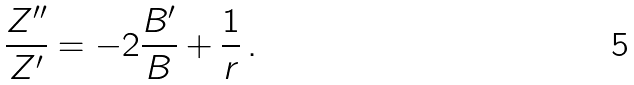<formula> <loc_0><loc_0><loc_500><loc_500>\frac { Z ^ { \prime \prime } } { Z ^ { \prime } } = - 2 \frac { B ^ { \prime } } { B } + \frac { 1 } { r } \, .</formula> 